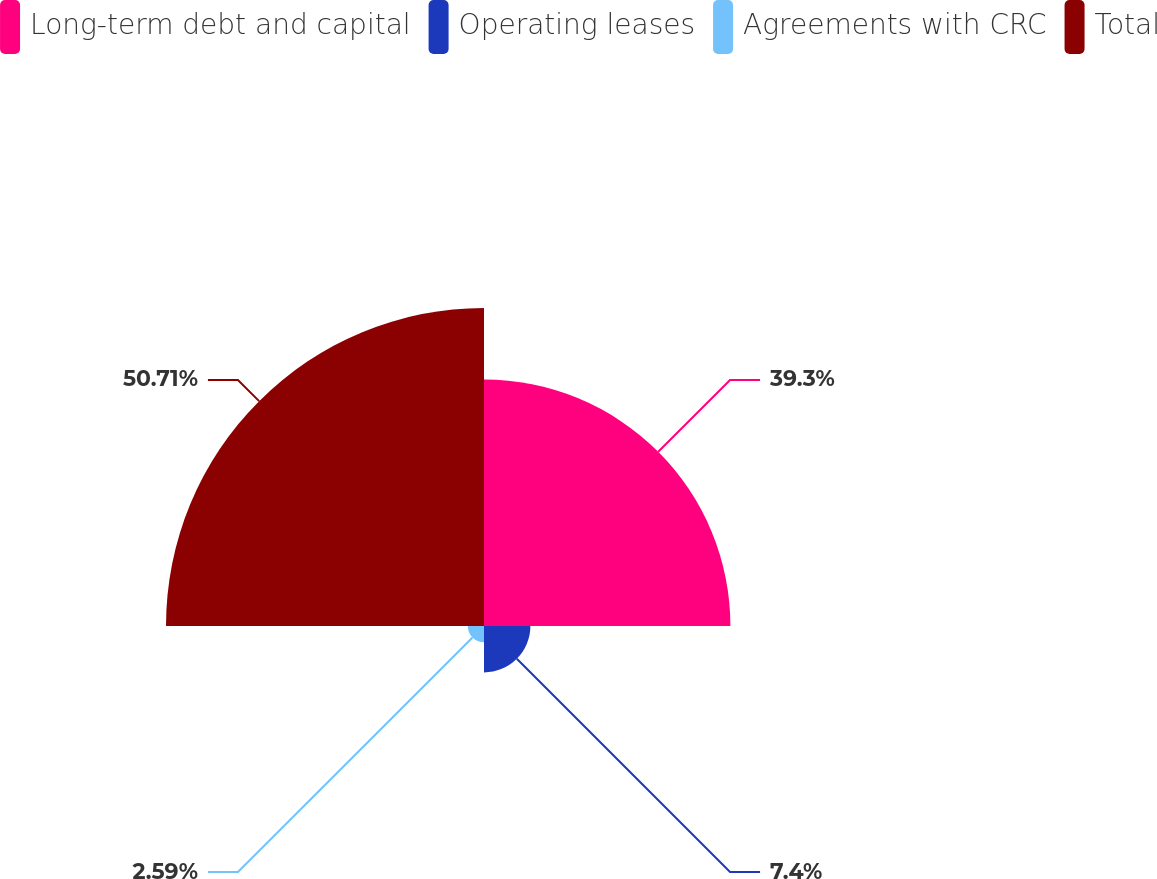Convert chart. <chart><loc_0><loc_0><loc_500><loc_500><pie_chart><fcel>Long-term debt and capital<fcel>Operating leases<fcel>Agreements with CRC<fcel>Total<nl><fcel>39.3%<fcel>7.4%<fcel>2.59%<fcel>50.72%<nl></chart> 